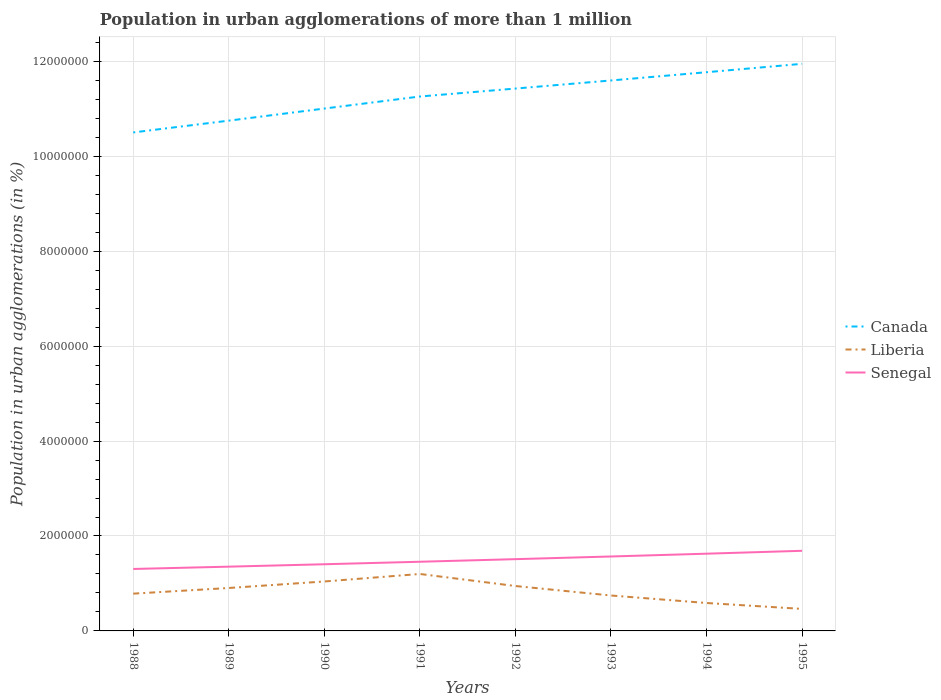How many different coloured lines are there?
Provide a short and direct response. 3. Does the line corresponding to Senegal intersect with the line corresponding to Liberia?
Your answer should be compact. No. Is the number of lines equal to the number of legend labels?
Make the answer very short. Yes. Across all years, what is the maximum population in urban agglomerations in Senegal?
Provide a succinct answer. 1.31e+06. In which year was the population in urban agglomerations in Canada maximum?
Offer a terse response. 1988. What is the total population in urban agglomerations in Liberia in the graph?
Your answer should be very brief. -1.58e+05. What is the difference between the highest and the second highest population in urban agglomerations in Senegal?
Offer a terse response. 3.83e+05. Is the population in urban agglomerations in Senegal strictly greater than the population in urban agglomerations in Liberia over the years?
Your answer should be very brief. No. Are the values on the major ticks of Y-axis written in scientific E-notation?
Your answer should be very brief. No. Does the graph contain any zero values?
Ensure brevity in your answer.  No. Where does the legend appear in the graph?
Keep it short and to the point. Center right. How are the legend labels stacked?
Give a very brief answer. Vertical. What is the title of the graph?
Your answer should be very brief. Population in urban agglomerations of more than 1 million. Does "Slovak Republic" appear as one of the legend labels in the graph?
Your response must be concise. No. What is the label or title of the X-axis?
Keep it short and to the point. Years. What is the label or title of the Y-axis?
Your answer should be compact. Population in urban agglomerations (in %). What is the Population in urban agglomerations (in %) of Canada in 1988?
Give a very brief answer. 1.05e+07. What is the Population in urban agglomerations (in %) of Liberia in 1988?
Offer a very short reply. 7.86e+05. What is the Population in urban agglomerations (in %) of Senegal in 1988?
Give a very brief answer. 1.31e+06. What is the Population in urban agglomerations (in %) in Canada in 1989?
Your answer should be compact. 1.08e+07. What is the Population in urban agglomerations (in %) of Liberia in 1989?
Your response must be concise. 9.05e+05. What is the Population in urban agglomerations (in %) of Senegal in 1989?
Provide a succinct answer. 1.35e+06. What is the Population in urban agglomerations (in %) in Canada in 1990?
Ensure brevity in your answer.  1.10e+07. What is the Population in urban agglomerations (in %) of Liberia in 1990?
Ensure brevity in your answer.  1.04e+06. What is the Population in urban agglomerations (in %) in Senegal in 1990?
Ensure brevity in your answer.  1.40e+06. What is the Population in urban agglomerations (in %) in Canada in 1991?
Ensure brevity in your answer.  1.13e+07. What is the Population in urban agglomerations (in %) of Liberia in 1991?
Offer a terse response. 1.20e+06. What is the Population in urban agglomerations (in %) in Senegal in 1991?
Your answer should be compact. 1.46e+06. What is the Population in urban agglomerations (in %) in Canada in 1992?
Offer a very short reply. 1.14e+07. What is the Population in urban agglomerations (in %) in Liberia in 1992?
Keep it short and to the point. 9.46e+05. What is the Population in urban agglomerations (in %) of Senegal in 1992?
Make the answer very short. 1.51e+06. What is the Population in urban agglomerations (in %) in Canada in 1993?
Give a very brief answer. 1.16e+07. What is the Population in urban agglomerations (in %) of Liberia in 1993?
Ensure brevity in your answer.  7.46e+05. What is the Population in urban agglomerations (in %) in Senegal in 1993?
Provide a short and direct response. 1.57e+06. What is the Population in urban agglomerations (in %) in Canada in 1994?
Provide a short and direct response. 1.18e+07. What is the Population in urban agglomerations (in %) in Liberia in 1994?
Ensure brevity in your answer.  5.88e+05. What is the Population in urban agglomerations (in %) in Senegal in 1994?
Offer a very short reply. 1.63e+06. What is the Population in urban agglomerations (in %) in Canada in 1995?
Provide a short and direct response. 1.19e+07. What is the Population in urban agglomerations (in %) of Liberia in 1995?
Make the answer very short. 4.64e+05. What is the Population in urban agglomerations (in %) of Senegal in 1995?
Your answer should be compact. 1.69e+06. Across all years, what is the maximum Population in urban agglomerations (in %) in Canada?
Ensure brevity in your answer.  1.19e+07. Across all years, what is the maximum Population in urban agglomerations (in %) of Liberia?
Your response must be concise. 1.20e+06. Across all years, what is the maximum Population in urban agglomerations (in %) of Senegal?
Your answer should be compact. 1.69e+06. Across all years, what is the minimum Population in urban agglomerations (in %) in Canada?
Your answer should be compact. 1.05e+07. Across all years, what is the minimum Population in urban agglomerations (in %) in Liberia?
Provide a short and direct response. 4.64e+05. Across all years, what is the minimum Population in urban agglomerations (in %) in Senegal?
Ensure brevity in your answer.  1.31e+06. What is the total Population in urban agglomerations (in %) of Canada in the graph?
Your answer should be compact. 9.03e+07. What is the total Population in urban agglomerations (in %) of Liberia in the graph?
Offer a terse response. 6.68e+06. What is the total Population in urban agglomerations (in %) of Senegal in the graph?
Provide a short and direct response. 1.19e+07. What is the difference between the Population in urban agglomerations (in %) of Canada in 1988 and that in 1989?
Your response must be concise. -2.48e+05. What is the difference between the Population in urban agglomerations (in %) in Liberia in 1988 and that in 1989?
Give a very brief answer. -1.19e+05. What is the difference between the Population in urban agglomerations (in %) in Senegal in 1988 and that in 1989?
Keep it short and to the point. -4.88e+04. What is the difference between the Population in urban agglomerations (in %) of Canada in 1988 and that in 1990?
Make the answer very short. -5.03e+05. What is the difference between the Population in urban agglomerations (in %) in Liberia in 1988 and that in 1990?
Provide a short and direct response. -2.56e+05. What is the difference between the Population in urban agglomerations (in %) in Senegal in 1988 and that in 1990?
Your answer should be compact. -9.95e+04. What is the difference between the Population in urban agglomerations (in %) of Canada in 1988 and that in 1991?
Provide a succinct answer. -7.57e+05. What is the difference between the Population in urban agglomerations (in %) in Liberia in 1988 and that in 1991?
Keep it short and to the point. -4.14e+05. What is the difference between the Population in urban agglomerations (in %) of Senegal in 1988 and that in 1991?
Offer a terse response. -1.52e+05. What is the difference between the Population in urban agglomerations (in %) of Canada in 1988 and that in 1992?
Offer a very short reply. -9.24e+05. What is the difference between the Population in urban agglomerations (in %) of Liberia in 1988 and that in 1992?
Provide a succinct answer. -1.60e+05. What is the difference between the Population in urban agglomerations (in %) in Senegal in 1988 and that in 1992?
Offer a very short reply. -2.07e+05. What is the difference between the Population in urban agglomerations (in %) in Canada in 1988 and that in 1993?
Offer a terse response. -1.09e+06. What is the difference between the Population in urban agglomerations (in %) of Liberia in 1988 and that in 1993?
Provide a succinct answer. 3.93e+04. What is the difference between the Population in urban agglomerations (in %) of Senegal in 1988 and that in 1993?
Provide a succinct answer. -2.63e+05. What is the difference between the Population in urban agglomerations (in %) in Canada in 1988 and that in 1994?
Your answer should be compact. -1.27e+06. What is the difference between the Population in urban agglomerations (in %) of Liberia in 1988 and that in 1994?
Provide a short and direct response. 1.97e+05. What is the difference between the Population in urban agglomerations (in %) of Senegal in 1988 and that in 1994?
Provide a succinct answer. -3.22e+05. What is the difference between the Population in urban agglomerations (in %) in Canada in 1988 and that in 1995?
Ensure brevity in your answer.  -1.45e+06. What is the difference between the Population in urban agglomerations (in %) in Liberia in 1988 and that in 1995?
Keep it short and to the point. 3.22e+05. What is the difference between the Population in urban agglomerations (in %) in Senegal in 1988 and that in 1995?
Your response must be concise. -3.83e+05. What is the difference between the Population in urban agglomerations (in %) in Canada in 1989 and that in 1990?
Your answer should be compact. -2.55e+05. What is the difference between the Population in urban agglomerations (in %) in Liberia in 1989 and that in 1990?
Offer a terse response. -1.37e+05. What is the difference between the Population in urban agglomerations (in %) of Senegal in 1989 and that in 1990?
Your response must be concise. -5.07e+04. What is the difference between the Population in urban agglomerations (in %) of Canada in 1989 and that in 1991?
Ensure brevity in your answer.  -5.09e+05. What is the difference between the Population in urban agglomerations (in %) in Liberia in 1989 and that in 1991?
Ensure brevity in your answer.  -2.95e+05. What is the difference between the Population in urban agglomerations (in %) in Senegal in 1989 and that in 1991?
Provide a short and direct response. -1.03e+05. What is the difference between the Population in urban agglomerations (in %) of Canada in 1989 and that in 1992?
Your answer should be very brief. -6.76e+05. What is the difference between the Population in urban agglomerations (in %) of Liberia in 1989 and that in 1992?
Make the answer very short. -4.14e+04. What is the difference between the Population in urban agglomerations (in %) of Senegal in 1989 and that in 1992?
Provide a succinct answer. -1.58e+05. What is the difference between the Population in urban agglomerations (in %) in Canada in 1989 and that in 1993?
Give a very brief answer. -8.47e+05. What is the difference between the Population in urban agglomerations (in %) of Liberia in 1989 and that in 1993?
Keep it short and to the point. 1.58e+05. What is the difference between the Population in urban agglomerations (in %) in Senegal in 1989 and that in 1993?
Make the answer very short. -2.14e+05. What is the difference between the Population in urban agglomerations (in %) of Canada in 1989 and that in 1994?
Your response must be concise. -1.02e+06. What is the difference between the Population in urban agglomerations (in %) in Liberia in 1989 and that in 1994?
Offer a terse response. 3.16e+05. What is the difference between the Population in urban agglomerations (in %) of Senegal in 1989 and that in 1994?
Provide a succinct answer. -2.73e+05. What is the difference between the Population in urban agglomerations (in %) of Canada in 1989 and that in 1995?
Give a very brief answer. -1.20e+06. What is the difference between the Population in urban agglomerations (in %) of Liberia in 1989 and that in 1995?
Provide a short and direct response. 4.41e+05. What is the difference between the Population in urban agglomerations (in %) of Senegal in 1989 and that in 1995?
Your answer should be compact. -3.34e+05. What is the difference between the Population in urban agglomerations (in %) of Canada in 1990 and that in 1991?
Your answer should be compact. -2.54e+05. What is the difference between the Population in urban agglomerations (in %) of Liberia in 1990 and that in 1991?
Provide a succinct answer. -1.58e+05. What is the difference between the Population in urban agglomerations (in %) in Senegal in 1990 and that in 1991?
Your answer should be very brief. -5.26e+04. What is the difference between the Population in urban agglomerations (in %) in Canada in 1990 and that in 1992?
Offer a terse response. -4.21e+05. What is the difference between the Population in urban agglomerations (in %) of Liberia in 1990 and that in 1992?
Offer a terse response. 9.59e+04. What is the difference between the Population in urban agglomerations (in %) of Senegal in 1990 and that in 1992?
Give a very brief answer. -1.07e+05. What is the difference between the Population in urban agglomerations (in %) of Canada in 1990 and that in 1993?
Keep it short and to the point. -5.92e+05. What is the difference between the Population in urban agglomerations (in %) of Liberia in 1990 and that in 1993?
Give a very brief answer. 2.96e+05. What is the difference between the Population in urban agglomerations (in %) in Senegal in 1990 and that in 1993?
Provide a succinct answer. -1.64e+05. What is the difference between the Population in urban agglomerations (in %) of Canada in 1990 and that in 1994?
Provide a short and direct response. -7.65e+05. What is the difference between the Population in urban agglomerations (in %) in Liberia in 1990 and that in 1994?
Offer a terse response. 4.53e+05. What is the difference between the Population in urban agglomerations (in %) of Senegal in 1990 and that in 1994?
Your answer should be compact. -2.22e+05. What is the difference between the Population in urban agglomerations (in %) of Canada in 1990 and that in 1995?
Your answer should be very brief. -9.42e+05. What is the difference between the Population in urban agglomerations (in %) in Liberia in 1990 and that in 1995?
Give a very brief answer. 5.78e+05. What is the difference between the Population in urban agglomerations (in %) of Senegal in 1990 and that in 1995?
Make the answer very short. -2.83e+05. What is the difference between the Population in urban agglomerations (in %) in Canada in 1991 and that in 1992?
Your answer should be compact. -1.68e+05. What is the difference between the Population in urban agglomerations (in %) of Liberia in 1991 and that in 1992?
Offer a terse response. 2.54e+05. What is the difference between the Population in urban agglomerations (in %) in Senegal in 1991 and that in 1992?
Your answer should be very brief. -5.46e+04. What is the difference between the Population in urban agglomerations (in %) in Canada in 1991 and that in 1993?
Ensure brevity in your answer.  -3.38e+05. What is the difference between the Population in urban agglomerations (in %) of Liberia in 1991 and that in 1993?
Offer a very short reply. 4.54e+05. What is the difference between the Population in urban agglomerations (in %) in Senegal in 1991 and that in 1993?
Provide a succinct answer. -1.11e+05. What is the difference between the Population in urban agglomerations (in %) in Canada in 1991 and that in 1994?
Keep it short and to the point. -5.12e+05. What is the difference between the Population in urban agglomerations (in %) of Liberia in 1991 and that in 1994?
Your answer should be very brief. 6.12e+05. What is the difference between the Population in urban agglomerations (in %) in Senegal in 1991 and that in 1994?
Your response must be concise. -1.70e+05. What is the difference between the Population in urban agglomerations (in %) in Canada in 1991 and that in 1995?
Make the answer very short. -6.89e+05. What is the difference between the Population in urban agglomerations (in %) in Liberia in 1991 and that in 1995?
Give a very brief answer. 7.36e+05. What is the difference between the Population in urban agglomerations (in %) in Senegal in 1991 and that in 1995?
Provide a short and direct response. -2.31e+05. What is the difference between the Population in urban agglomerations (in %) of Canada in 1992 and that in 1993?
Keep it short and to the point. -1.70e+05. What is the difference between the Population in urban agglomerations (in %) of Liberia in 1992 and that in 1993?
Make the answer very short. 2.00e+05. What is the difference between the Population in urban agglomerations (in %) in Senegal in 1992 and that in 1993?
Your response must be concise. -5.65e+04. What is the difference between the Population in urban agglomerations (in %) of Canada in 1992 and that in 1994?
Ensure brevity in your answer.  -3.44e+05. What is the difference between the Population in urban agglomerations (in %) of Liberia in 1992 and that in 1994?
Your answer should be very brief. 3.58e+05. What is the difference between the Population in urban agglomerations (in %) in Senegal in 1992 and that in 1994?
Your answer should be compact. -1.15e+05. What is the difference between the Population in urban agglomerations (in %) of Canada in 1992 and that in 1995?
Provide a succinct answer. -5.21e+05. What is the difference between the Population in urban agglomerations (in %) in Liberia in 1992 and that in 1995?
Your answer should be compact. 4.82e+05. What is the difference between the Population in urban agglomerations (in %) in Senegal in 1992 and that in 1995?
Provide a short and direct response. -1.76e+05. What is the difference between the Population in urban agglomerations (in %) of Canada in 1993 and that in 1994?
Provide a short and direct response. -1.74e+05. What is the difference between the Population in urban agglomerations (in %) of Liberia in 1993 and that in 1994?
Your answer should be compact. 1.58e+05. What is the difference between the Population in urban agglomerations (in %) in Senegal in 1993 and that in 1994?
Your answer should be very brief. -5.87e+04. What is the difference between the Population in urban agglomerations (in %) in Canada in 1993 and that in 1995?
Offer a very short reply. -3.51e+05. What is the difference between the Population in urban agglomerations (in %) of Liberia in 1993 and that in 1995?
Give a very brief answer. 2.82e+05. What is the difference between the Population in urban agglomerations (in %) of Senegal in 1993 and that in 1995?
Your response must be concise. -1.20e+05. What is the difference between the Population in urban agglomerations (in %) in Canada in 1994 and that in 1995?
Ensure brevity in your answer.  -1.77e+05. What is the difference between the Population in urban agglomerations (in %) in Liberia in 1994 and that in 1995?
Provide a succinct answer. 1.24e+05. What is the difference between the Population in urban agglomerations (in %) in Senegal in 1994 and that in 1995?
Give a very brief answer. -6.09e+04. What is the difference between the Population in urban agglomerations (in %) of Canada in 1988 and the Population in urban agglomerations (in %) of Liberia in 1989?
Offer a very short reply. 9.60e+06. What is the difference between the Population in urban agglomerations (in %) of Canada in 1988 and the Population in urban agglomerations (in %) of Senegal in 1989?
Your answer should be compact. 9.15e+06. What is the difference between the Population in urban agglomerations (in %) of Liberia in 1988 and the Population in urban agglomerations (in %) of Senegal in 1989?
Your answer should be compact. -5.69e+05. What is the difference between the Population in urban agglomerations (in %) in Canada in 1988 and the Population in urban agglomerations (in %) in Liberia in 1990?
Your answer should be compact. 9.46e+06. What is the difference between the Population in urban agglomerations (in %) of Canada in 1988 and the Population in urban agglomerations (in %) of Senegal in 1990?
Offer a very short reply. 9.10e+06. What is the difference between the Population in urban agglomerations (in %) in Liberia in 1988 and the Population in urban agglomerations (in %) in Senegal in 1990?
Your answer should be compact. -6.19e+05. What is the difference between the Population in urban agglomerations (in %) in Canada in 1988 and the Population in urban agglomerations (in %) in Liberia in 1991?
Your answer should be compact. 9.30e+06. What is the difference between the Population in urban agglomerations (in %) in Canada in 1988 and the Population in urban agglomerations (in %) in Senegal in 1991?
Ensure brevity in your answer.  9.05e+06. What is the difference between the Population in urban agglomerations (in %) in Liberia in 1988 and the Population in urban agglomerations (in %) in Senegal in 1991?
Ensure brevity in your answer.  -6.72e+05. What is the difference between the Population in urban agglomerations (in %) of Canada in 1988 and the Population in urban agglomerations (in %) of Liberia in 1992?
Give a very brief answer. 9.56e+06. What is the difference between the Population in urban agglomerations (in %) of Canada in 1988 and the Population in urban agglomerations (in %) of Senegal in 1992?
Your answer should be compact. 8.99e+06. What is the difference between the Population in urban agglomerations (in %) of Liberia in 1988 and the Population in urban agglomerations (in %) of Senegal in 1992?
Provide a succinct answer. -7.26e+05. What is the difference between the Population in urban agglomerations (in %) in Canada in 1988 and the Population in urban agglomerations (in %) in Liberia in 1993?
Offer a very short reply. 9.76e+06. What is the difference between the Population in urban agglomerations (in %) of Canada in 1988 and the Population in urban agglomerations (in %) of Senegal in 1993?
Offer a terse response. 8.93e+06. What is the difference between the Population in urban agglomerations (in %) of Liberia in 1988 and the Population in urban agglomerations (in %) of Senegal in 1993?
Ensure brevity in your answer.  -7.83e+05. What is the difference between the Population in urban agglomerations (in %) in Canada in 1988 and the Population in urban agglomerations (in %) in Liberia in 1994?
Offer a terse response. 9.91e+06. What is the difference between the Population in urban agglomerations (in %) of Canada in 1988 and the Population in urban agglomerations (in %) of Senegal in 1994?
Offer a very short reply. 8.88e+06. What is the difference between the Population in urban agglomerations (in %) in Liberia in 1988 and the Population in urban agglomerations (in %) in Senegal in 1994?
Offer a very short reply. -8.42e+05. What is the difference between the Population in urban agglomerations (in %) in Canada in 1988 and the Population in urban agglomerations (in %) in Liberia in 1995?
Offer a very short reply. 1.00e+07. What is the difference between the Population in urban agglomerations (in %) in Canada in 1988 and the Population in urban agglomerations (in %) in Senegal in 1995?
Make the answer very short. 8.81e+06. What is the difference between the Population in urban agglomerations (in %) of Liberia in 1988 and the Population in urban agglomerations (in %) of Senegal in 1995?
Ensure brevity in your answer.  -9.03e+05. What is the difference between the Population in urban agglomerations (in %) in Canada in 1989 and the Population in urban agglomerations (in %) in Liberia in 1990?
Your answer should be very brief. 9.71e+06. What is the difference between the Population in urban agglomerations (in %) of Canada in 1989 and the Population in urban agglomerations (in %) of Senegal in 1990?
Your response must be concise. 9.35e+06. What is the difference between the Population in urban agglomerations (in %) of Liberia in 1989 and the Population in urban agglomerations (in %) of Senegal in 1990?
Ensure brevity in your answer.  -5.00e+05. What is the difference between the Population in urban agglomerations (in %) in Canada in 1989 and the Population in urban agglomerations (in %) in Liberia in 1991?
Your answer should be very brief. 9.55e+06. What is the difference between the Population in urban agglomerations (in %) in Canada in 1989 and the Population in urban agglomerations (in %) in Senegal in 1991?
Keep it short and to the point. 9.29e+06. What is the difference between the Population in urban agglomerations (in %) in Liberia in 1989 and the Population in urban agglomerations (in %) in Senegal in 1991?
Make the answer very short. -5.53e+05. What is the difference between the Population in urban agglomerations (in %) of Canada in 1989 and the Population in urban agglomerations (in %) of Liberia in 1992?
Ensure brevity in your answer.  9.81e+06. What is the difference between the Population in urban agglomerations (in %) in Canada in 1989 and the Population in urban agglomerations (in %) in Senegal in 1992?
Give a very brief answer. 9.24e+06. What is the difference between the Population in urban agglomerations (in %) of Liberia in 1989 and the Population in urban agglomerations (in %) of Senegal in 1992?
Keep it short and to the point. -6.07e+05. What is the difference between the Population in urban agglomerations (in %) of Canada in 1989 and the Population in urban agglomerations (in %) of Liberia in 1993?
Keep it short and to the point. 1.00e+07. What is the difference between the Population in urban agglomerations (in %) of Canada in 1989 and the Population in urban agglomerations (in %) of Senegal in 1993?
Your response must be concise. 9.18e+06. What is the difference between the Population in urban agglomerations (in %) of Liberia in 1989 and the Population in urban agglomerations (in %) of Senegal in 1993?
Provide a short and direct response. -6.64e+05. What is the difference between the Population in urban agglomerations (in %) of Canada in 1989 and the Population in urban agglomerations (in %) of Liberia in 1994?
Provide a succinct answer. 1.02e+07. What is the difference between the Population in urban agglomerations (in %) in Canada in 1989 and the Population in urban agglomerations (in %) in Senegal in 1994?
Offer a terse response. 9.12e+06. What is the difference between the Population in urban agglomerations (in %) in Liberia in 1989 and the Population in urban agglomerations (in %) in Senegal in 1994?
Your answer should be very brief. -7.23e+05. What is the difference between the Population in urban agglomerations (in %) of Canada in 1989 and the Population in urban agglomerations (in %) of Liberia in 1995?
Your answer should be very brief. 1.03e+07. What is the difference between the Population in urban agglomerations (in %) in Canada in 1989 and the Population in urban agglomerations (in %) in Senegal in 1995?
Offer a terse response. 9.06e+06. What is the difference between the Population in urban agglomerations (in %) in Liberia in 1989 and the Population in urban agglomerations (in %) in Senegal in 1995?
Offer a terse response. -7.83e+05. What is the difference between the Population in urban agglomerations (in %) of Canada in 1990 and the Population in urban agglomerations (in %) of Liberia in 1991?
Offer a terse response. 9.81e+06. What is the difference between the Population in urban agglomerations (in %) of Canada in 1990 and the Population in urban agglomerations (in %) of Senegal in 1991?
Give a very brief answer. 9.55e+06. What is the difference between the Population in urban agglomerations (in %) of Liberia in 1990 and the Population in urban agglomerations (in %) of Senegal in 1991?
Make the answer very short. -4.15e+05. What is the difference between the Population in urban agglomerations (in %) in Canada in 1990 and the Population in urban agglomerations (in %) in Liberia in 1992?
Make the answer very short. 1.01e+07. What is the difference between the Population in urban agglomerations (in %) of Canada in 1990 and the Population in urban agglomerations (in %) of Senegal in 1992?
Your response must be concise. 9.49e+06. What is the difference between the Population in urban agglomerations (in %) in Liberia in 1990 and the Population in urban agglomerations (in %) in Senegal in 1992?
Your response must be concise. -4.70e+05. What is the difference between the Population in urban agglomerations (in %) of Canada in 1990 and the Population in urban agglomerations (in %) of Liberia in 1993?
Make the answer very short. 1.03e+07. What is the difference between the Population in urban agglomerations (in %) of Canada in 1990 and the Population in urban agglomerations (in %) of Senegal in 1993?
Provide a succinct answer. 9.44e+06. What is the difference between the Population in urban agglomerations (in %) in Liberia in 1990 and the Population in urban agglomerations (in %) in Senegal in 1993?
Provide a succinct answer. -5.27e+05. What is the difference between the Population in urban agglomerations (in %) in Canada in 1990 and the Population in urban agglomerations (in %) in Liberia in 1994?
Offer a very short reply. 1.04e+07. What is the difference between the Population in urban agglomerations (in %) in Canada in 1990 and the Population in urban agglomerations (in %) in Senegal in 1994?
Your answer should be compact. 9.38e+06. What is the difference between the Population in urban agglomerations (in %) of Liberia in 1990 and the Population in urban agglomerations (in %) of Senegal in 1994?
Ensure brevity in your answer.  -5.85e+05. What is the difference between the Population in urban agglomerations (in %) in Canada in 1990 and the Population in urban agglomerations (in %) in Liberia in 1995?
Provide a succinct answer. 1.05e+07. What is the difference between the Population in urban agglomerations (in %) of Canada in 1990 and the Population in urban agglomerations (in %) of Senegal in 1995?
Provide a short and direct response. 9.32e+06. What is the difference between the Population in urban agglomerations (in %) in Liberia in 1990 and the Population in urban agglomerations (in %) in Senegal in 1995?
Your answer should be compact. -6.46e+05. What is the difference between the Population in urban agglomerations (in %) in Canada in 1991 and the Population in urban agglomerations (in %) in Liberia in 1992?
Keep it short and to the point. 1.03e+07. What is the difference between the Population in urban agglomerations (in %) of Canada in 1991 and the Population in urban agglomerations (in %) of Senegal in 1992?
Your response must be concise. 9.75e+06. What is the difference between the Population in urban agglomerations (in %) of Liberia in 1991 and the Population in urban agglomerations (in %) of Senegal in 1992?
Make the answer very short. -3.12e+05. What is the difference between the Population in urban agglomerations (in %) in Canada in 1991 and the Population in urban agglomerations (in %) in Liberia in 1993?
Keep it short and to the point. 1.05e+07. What is the difference between the Population in urban agglomerations (in %) of Canada in 1991 and the Population in urban agglomerations (in %) of Senegal in 1993?
Give a very brief answer. 9.69e+06. What is the difference between the Population in urban agglomerations (in %) of Liberia in 1991 and the Population in urban agglomerations (in %) of Senegal in 1993?
Make the answer very short. -3.68e+05. What is the difference between the Population in urban agglomerations (in %) of Canada in 1991 and the Population in urban agglomerations (in %) of Liberia in 1994?
Your response must be concise. 1.07e+07. What is the difference between the Population in urban agglomerations (in %) in Canada in 1991 and the Population in urban agglomerations (in %) in Senegal in 1994?
Keep it short and to the point. 9.63e+06. What is the difference between the Population in urban agglomerations (in %) of Liberia in 1991 and the Population in urban agglomerations (in %) of Senegal in 1994?
Your answer should be compact. -4.27e+05. What is the difference between the Population in urban agglomerations (in %) in Canada in 1991 and the Population in urban agglomerations (in %) in Liberia in 1995?
Provide a succinct answer. 1.08e+07. What is the difference between the Population in urban agglomerations (in %) of Canada in 1991 and the Population in urban agglomerations (in %) of Senegal in 1995?
Your answer should be very brief. 9.57e+06. What is the difference between the Population in urban agglomerations (in %) of Liberia in 1991 and the Population in urban agglomerations (in %) of Senegal in 1995?
Make the answer very short. -4.88e+05. What is the difference between the Population in urban agglomerations (in %) in Canada in 1992 and the Population in urban agglomerations (in %) in Liberia in 1993?
Your answer should be very brief. 1.07e+07. What is the difference between the Population in urban agglomerations (in %) in Canada in 1992 and the Population in urban agglomerations (in %) in Senegal in 1993?
Give a very brief answer. 9.86e+06. What is the difference between the Population in urban agglomerations (in %) in Liberia in 1992 and the Population in urban agglomerations (in %) in Senegal in 1993?
Your response must be concise. -6.22e+05. What is the difference between the Population in urban agglomerations (in %) in Canada in 1992 and the Population in urban agglomerations (in %) in Liberia in 1994?
Provide a short and direct response. 1.08e+07. What is the difference between the Population in urban agglomerations (in %) in Canada in 1992 and the Population in urban agglomerations (in %) in Senegal in 1994?
Offer a very short reply. 9.80e+06. What is the difference between the Population in urban agglomerations (in %) of Liberia in 1992 and the Population in urban agglomerations (in %) of Senegal in 1994?
Your answer should be very brief. -6.81e+05. What is the difference between the Population in urban agglomerations (in %) in Canada in 1992 and the Population in urban agglomerations (in %) in Liberia in 1995?
Keep it short and to the point. 1.10e+07. What is the difference between the Population in urban agglomerations (in %) of Canada in 1992 and the Population in urban agglomerations (in %) of Senegal in 1995?
Your response must be concise. 9.74e+06. What is the difference between the Population in urban agglomerations (in %) in Liberia in 1992 and the Population in urban agglomerations (in %) in Senegal in 1995?
Your response must be concise. -7.42e+05. What is the difference between the Population in urban agglomerations (in %) in Canada in 1993 and the Population in urban agglomerations (in %) in Liberia in 1994?
Offer a very short reply. 1.10e+07. What is the difference between the Population in urban agglomerations (in %) in Canada in 1993 and the Population in urban agglomerations (in %) in Senegal in 1994?
Give a very brief answer. 9.97e+06. What is the difference between the Population in urban agglomerations (in %) in Liberia in 1993 and the Population in urban agglomerations (in %) in Senegal in 1994?
Provide a succinct answer. -8.81e+05. What is the difference between the Population in urban agglomerations (in %) in Canada in 1993 and the Population in urban agglomerations (in %) in Liberia in 1995?
Give a very brief answer. 1.11e+07. What is the difference between the Population in urban agglomerations (in %) of Canada in 1993 and the Population in urban agglomerations (in %) of Senegal in 1995?
Keep it short and to the point. 9.91e+06. What is the difference between the Population in urban agglomerations (in %) in Liberia in 1993 and the Population in urban agglomerations (in %) in Senegal in 1995?
Ensure brevity in your answer.  -9.42e+05. What is the difference between the Population in urban agglomerations (in %) of Canada in 1994 and the Population in urban agglomerations (in %) of Liberia in 1995?
Provide a succinct answer. 1.13e+07. What is the difference between the Population in urban agglomerations (in %) in Canada in 1994 and the Population in urban agglomerations (in %) in Senegal in 1995?
Make the answer very short. 1.01e+07. What is the difference between the Population in urban agglomerations (in %) of Liberia in 1994 and the Population in urban agglomerations (in %) of Senegal in 1995?
Your answer should be very brief. -1.10e+06. What is the average Population in urban agglomerations (in %) in Canada per year?
Provide a succinct answer. 1.13e+07. What is the average Population in urban agglomerations (in %) in Liberia per year?
Offer a very short reply. 8.35e+05. What is the average Population in urban agglomerations (in %) of Senegal per year?
Your answer should be compact. 1.49e+06. In the year 1988, what is the difference between the Population in urban agglomerations (in %) in Canada and Population in urban agglomerations (in %) in Liberia?
Your answer should be compact. 9.72e+06. In the year 1988, what is the difference between the Population in urban agglomerations (in %) of Canada and Population in urban agglomerations (in %) of Senegal?
Keep it short and to the point. 9.20e+06. In the year 1988, what is the difference between the Population in urban agglomerations (in %) of Liberia and Population in urban agglomerations (in %) of Senegal?
Make the answer very short. -5.20e+05. In the year 1989, what is the difference between the Population in urban agglomerations (in %) of Canada and Population in urban agglomerations (in %) of Liberia?
Provide a succinct answer. 9.85e+06. In the year 1989, what is the difference between the Population in urban agglomerations (in %) in Canada and Population in urban agglomerations (in %) in Senegal?
Provide a short and direct response. 9.40e+06. In the year 1989, what is the difference between the Population in urban agglomerations (in %) in Liberia and Population in urban agglomerations (in %) in Senegal?
Give a very brief answer. -4.49e+05. In the year 1990, what is the difference between the Population in urban agglomerations (in %) of Canada and Population in urban agglomerations (in %) of Liberia?
Provide a short and direct response. 9.96e+06. In the year 1990, what is the difference between the Population in urban agglomerations (in %) of Canada and Population in urban agglomerations (in %) of Senegal?
Keep it short and to the point. 9.60e+06. In the year 1990, what is the difference between the Population in urban agglomerations (in %) of Liberia and Population in urban agglomerations (in %) of Senegal?
Ensure brevity in your answer.  -3.63e+05. In the year 1991, what is the difference between the Population in urban agglomerations (in %) in Canada and Population in urban agglomerations (in %) in Liberia?
Your answer should be compact. 1.01e+07. In the year 1991, what is the difference between the Population in urban agglomerations (in %) of Canada and Population in urban agglomerations (in %) of Senegal?
Provide a succinct answer. 9.80e+06. In the year 1991, what is the difference between the Population in urban agglomerations (in %) of Liberia and Population in urban agglomerations (in %) of Senegal?
Your response must be concise. -2.57e+05. In the year 1992, what is the difference between the Population in urban agglomerations (in %) in Canada and Population in urban agglomerations (in %) in Liberia?
Offer a terse response. 1.05e+07. In the year 1992, what is the difference between the Population in urban agglomerations (in %) in Canada and Population in urban agglomerations (in %) in Senegal?
Offer a very short reply. 9.92e+06. In the year 1992, what is the difference between the Population in urban agglomerations (in %) of Liberia and Population in urban agglomerations (in %) of Senegal?
Offer a very short reply. -5.66e+05. In the year 1993, what is the difference between the Population in urban agglomerations (in %) of Canada and Population in urban agglomerations (in %) of Liberia?
Provide a succinct answer. 1.09e+07. In the year 1993, what is the difference between the Population in urban agglomerations (in %) in Canada and Population in urban agglomerations (in %) in Senegal?
Provide a short and direct response. 1.00e+07. In the year 1993, what is the difference between the Population in urban agglomerations (in %) in Liberia and Population in urban agglomerations (in %) in Senegal?
Make the answer very short. -8.22e+05. In the year 1994, what is the difference between the Population in urban agglomerations (in %) in Canada and Population in urban agglomerations (in %) in Liberia?
Your response must be concise. 1.12e+07. In the year 1994, what is the difference between the Population in urban agglomerations (in %) of Canada and Population in urban agglomerations (in %) of Senegal?
Ensure brevity in your answer.  1.01e+07. In the year 1994, what is the difference between the Population in urban agglomerations (in %) of Liberia and Population in urban agglomerations (in %) of Senegal?
Your answer should be very brief. -1.04e+06. In the year 1995, what is the difference between the Population in urban agglomerations (in %) in Canada and Population in urban agglomerations (in %) in Liberia?
Offer a terse response. 1.15e+07. In the year 1995, what is the difference between the Population in urban agglomerations (in %) in Canada and Population in urban agglomerations (in %) in Senegal?
Provide a succinct answer. 1.03e+07. In the year 1995, what is the difference between the Population in urban agglomerations (in %) of Liberia and Population in urban agglomerations (in %) of Senegal?
Your answer should be compact. -1.22e+06. What is the ratio of the Population in urban agglomerations (in %) of Canada in 1988 to that in 1989?
Offer a terse response. 0.98. What is the ratio of the Population in urban agglomerations (in %) in Liberia in 1988 to that in 1989?
Your answer should be compact. 0.87. What is the ratio of the Population in urban agglomerations (in %) in Senegal in 1988 to that in 1989?
Keep it short and to the point. 0.96. What is the ratio of the Population in urban agglomerations (in %) of Canada in 1988 to that in 1990?
Your answer should be very brief. 0.95. What is the ratio of the Population in urban agglomerations (in %) of Liberia in 1988 to that in 1990?
Offer a terse response. 0.75. What is the ratio of the Population in urban agglomerations (in %) of Senegal in 1988 to that in 1990?
Provide a succinct answer. 0.93. What is the ratio of the Population in urban agglomerations (in %) of Canada in 1988 to that in 1991?
Offer a terse response. 0.93. What is the ratio of the Population in urban agglomerations (in %) of Liberia in 1988 to that in 1991?
Offer a terse response. 0.65. What is the ratio of the Population in urban agglomerations (in %) in Senegal in 1988 to that in 1991?
Offer a very short reply. 0.9. What is the ratio of the Population in urban agglomerations (in %) of Canada in 1988 to that in 1992?
Make the answer very short. 0.92. What is the ratio of the Population in urban agglomerations (in %) of Liberia in 1988 to that in 1992?
Your answer should be compact. 0.83. What is the ratio of the Population in urban agglomerations (in %) of Senegal in 1988 to that in 1992?
Make the answer very short. 0.86. What is the ratio of the Population in urban agglomerations (in %) in Canada in 1988 to that in 1993?
Provide a succinct answer. 0.91. What is the ratio of the Population in urban agglomerations (in %) in Liberia in 1988 to that in 1993?
Keep it short and to the point. 1.05. What is the ratio of the Population in urban agglomerations (in %) in Senegal in 1988 to that in 1993?
Your response must be concise. 0.83. What is the ratio of the Population in urban agglomerations (in %) in Canada in 1988 to that in 1994?
Provide a succinct answer. 0.89. What is the ratio of the Population in urban agglomerations (in %) in Liberia in 1988 to that in 1994?
Your answer should be compact. 1.33. What is the ratio of the Population in urban agglomerations (in %) of Senegal in 1988 to that in 1994?
Provide a succinct answer. 0.8. What is the ratio of the Population in urban agglomerations (in %) in Canada in 1988 to that in 1995?
Give a very brief answer. 0.88. What is the ratio of the Population in urban agglomerations (in %) in Liberia in 1988 to that in 1995?
Offer a terse response. 1.69. What is the ratio of the Population in urban agglomerations (in %) of Senegal in 1988 to that in 1995?
Provide a succinct answer. 0.77. What is the ratio of the Population in urban agglomerations (in %) of Canada in 1989 to that in 1990?
Your response must be concise. 0.98. What is the ratio of the Population in urban agglomerations (in %) of Liberia in 1989 to that in 1990?
Give a very brief answer. 0.87. What is the ratio of the Population in urban agglomerations (in %) in Senegal in 1989 to that in 1990?
Your response must be concise. 0.96. What is the ratio of the Population in urban agglomerations (in %) of Canada in 1989 to that in 1991?
Offer a terse response. 0.95. What is the ratio of the Population in urban agglomerations (in %) of Liberia in 1989 to that in 1991?
Ensure brevity in your answer.  0.75. What is the ratio of the Population in urban agglomerations (in %) in Senegal in 1989 to that in 1991?
Your answer should be compact. 0.93. What is the ratio of the Population in urban agglomerations (in %) of Canada in 1989 to that in 1992?
Provide a succinct answer. 0.94. What is the ratio of the Population in urban agglomerations (in %) in Liberia in 1989 to that in 1992?
Offer a terse response. 0.96. What is the ratio of the Population in urban agglomerations (in %) of Senegal in 1989 to that in 1992?
Keep it short and to the point. 0.9. What is the ratio of the Population in urban agglomerations (in %) in Canada in 1989 to that in 1993?
Your response must be concise. 0.93. What is the ratio of the Population in urban agglomerations (in %) of Liberia in 1989 to that in 1993?
Provide a succinct answer. 1.21. What is the ratio of the Population in urban agglomerations (in %) in Senegal in 1989 to that in 1993?
Your answer should be compact. 0.86. What is the ratio of the Population in urban agglomerations (in %) of Canada in 1989 to that in 1994?
Give a very brief answer. 0.91. What is the ratio of the Population in urban agglomerations (in %) of Liberia in 1989 to that in 1994?
Ensure brevity in your answer.  1.54. What is the ratio of the Population in urban agglomerations (in %) in Senegal in 1989 to that in 1994?
Your answer should be compact. 0.83. What is the ratio of the Population in urban agglomerations (in %) of Canada in 1989 to that in 1995?
Provide a succinct answer. 0.9. What is the ratio of the Population in urban agglomerations (in %) in Liberia in 1989 to that in 1995?
Ensure brevity in your answer.  1.95. What is the ratio of the Population in urban agglomerations (in %) in Senegal in 1989 to that in 1995?
Offer a very short reply. 0.8. What is the ratio of the Population in urban agglomerations (in %) in Canada in 1990 to that in 1991?
Your answer should be compact. 0.98. What is the ratio of the Population in urban agglomerations (in %) of Liberia in 1990 to that in 1991?
Provide a short and direct response. 0.87. What is the ratio of the Population in urban agglomerations (in %) in Senegal in 1990 to that in 1991?
Your response must be concise. 0.96. What is the ratio of the Population in urban agglomerations (in %) of Canada in 1990 to that in 1992?
Your answer should be very brief. 0.96. What is the ratio of the Population in urban agglomerations (in %) in Liberia in 1990 to that in 1992?
Provide a short and direct response. 1.1. What is the ratio of the Population in urban agglomerations (in %) in Senegal in 1990 to that in 1992?
Provide a short and direct response. 0.93. What is the ratio of the Population in urban agglomerations (in %) of Canada in 1990 to that in 1993?
Your answer should be compact. 0.95. What is the ratio of the Population in urban agglomerations (in %) in Liberia in 1990 to that in 1993?
Your response must be concise. 1.4. What is the ratio of the Population in urban agglomerations (in %) in Senegal in 1990 to that in 1993?
Make the answer very short. 0.9. What is the ratio of the Population in urban agglomerations (in %) of Canada in 1990 to that in 1994?
Offer a terse response. 0.94. What is the ratio of the Population in urban agglomerations (in %) of Liberia in 1990 to that in 1994?
Your response must be concise. 1.77. What is the ratio of the Population in urban agglomerations (in %) of Senegal in 1990 to that in 1994?
Provide a short and direct response. 0.86. What is the ratio of the Population in urban agglomerations (in %) in Canada in 1990 to that in 1995?
Offer a terse response. 0.92. What is the ratio of the Population in urban agglomerations (in %) in Liberia in 1990 to that in 1995?
Offer a terse response. 2.25. What is the ratio of the Population in urban agglomerations (in %) in Senegal in 1990 to that in 1995?
Ensure brevity in your answer.  0.83. What is the ratio of the Population in urban agglomerations (in %) in Canada in 1991 to that in 1992?
Provide a succinct answer. 0.99. What is the ratio of the Population in urban agglomerations (in %) in Liberia in 1991 to that in 1992?
Provide a short and direct response. 1.27. What is the ratio of the Population in urban agglomerations (in %) of Senegal in 1991 to that in 1992?
Your answer should be compact. 0.96. What is the ratio of the Population in urban agglomerations (in %) of Canada in 1991 to that in 1993?
Your answer should be compact. 0.97. What is the ratio of the Population in urban agglomerations (in %) of Liberia in 1991 to that in 1993?
Make the answer very short. 1.61. What is the ratio of the Population in urban agglomerations (in %) of Senegal in 1991 to that in 1993?
Offer a terse response. 0.93. What is the ratio of the Population in urban agglomerations (in %) of Canada in 1991 to that in 1994?
Offer a terse response. 0.96. What is the ratio of the Population in urban agglomerations (in %) in Liberia in 1991 to that in 1994?
Offer a very short reply. 2.04. What is the ratio of the Population in urban agglomerations (in %) in Senegal in 1991 to that in 1994?
Give a very brief answer. 0.9. What is the ratio of the Population in urban agglomerations (in %) in Canada in 1991 to that in 1995?
Make the answer very short. 0.94. What is the ratio of the Population in urban agglomerations (in %) of Liberia in 1991 to that in 1995?
Give a very brief answer. 2.59. What is the ratio of the Population in urban agglomerations (in %) in Senegal in 1991 to that in 1995?
Give a very brief answer. 0.86. What is the ratio of the Population in urban agglomerations (in %) in Liberia in 1992 to that in 1993?
Your response must be concise. 1.27. What is the ratio of the Population in urban agglomerations (in %) of Senegal in 1992 to that in 1993?
Your response must be concise. 0.96. What is the ratio of the Population in urban agglomerations (in %) in Canada in 1992 to that in 1994?
Give a very brief answer. 0.97. What is the ratio of the Population in urban agglomerations (in %) in Liberia in 1992 to that in 1994?
Your answer should be compact. 1.61. What is the ratio of the Population in urban agglomerations (in %) of Senegal in 1992 to that in 1994?
Keep it short and to the point. 0.93. What is the ratio of the Population in urban agglomerations (in %) of Canada in 1992 to that in 1995?
Provide a succinct answer. 0.96. What is the ratio of the Population in urban agglomerations (in %) in Liberia in 1992 to that in 1995?
Ensure brevity in your answer.  2.04. What is the ratio of the Population in urban agglomerations (in %) in Senegal in 1992 to that in 1995?
Offer a terse response. 0.9. What is the ratio of the Population in urban agglomerations (in %) in Canada in 1993 to that in 1994?
Make the answer very short. 0.99. What is the ratio of the Population in urban agglomerations (in %) of Liberia in 1993 to that in 1994?
Provide a succinct answer. 1.27. What is the ratio of the Population in urban agglomerations (in %) in Senegal in 1993 to that in 1994?
Provide a succinct answer. 0.96. What is the ratio of the Population in urban agglomerations (in %) of Canada in 1993 to that in 1995?
Make the answer very short. 0.97. What is the ratio of the Population in urban agglomerations (in %) in Liberia in 1993 to that in 1995?
Give a very brief answer. 1.61. What is the ratio of the Population in urban agglomerations (in %) of Senegal in 1993 to that in 1995?
Make the answer very short. 0.93. What is the ratio of the Population in urban agglomerations (in %) of Canada in 1994 to that in 1995?
Your answer should be very brief. 0.99. What is the ratio of the Population in urban agglomerations (in %) of Liberia in 1994 to that in 1995?
Make the answer very short. 1.27. What is the ratio of the Population in urban agglomerations (in %) of Senegal in 1994 to that in 1995?
Provide a succinct answer. 0.96. What is the difference between the highest and the second highest Population in urban agglomerations (in %) of Canada?
Provide a short and direct response. 1.77e+05. What is the difference between the highest and the second highest Population in urban agglomerations (in %) of Liberia?
Make the answer very short. 1.58e+05. What is the difference between the highest and the second highest Population in urban agglomerations (in %) in Senegal?
Provide a short and direct response. 6.09e+04. What is the difference between the highest and the lowest Population in urban agglomerations (in %) in Canada?
Keep it short and to the point. 1.45e+06. What is the difference between the highest and the lowest Population in urban agglomerations (in %) of Liberia?
Keep it short and to the point. 7.36e+05. What is the difference between the highest and the lowest Population in urban agglomerations (in %) in Senegal?
Your response must be concise. 3.83e+05. 